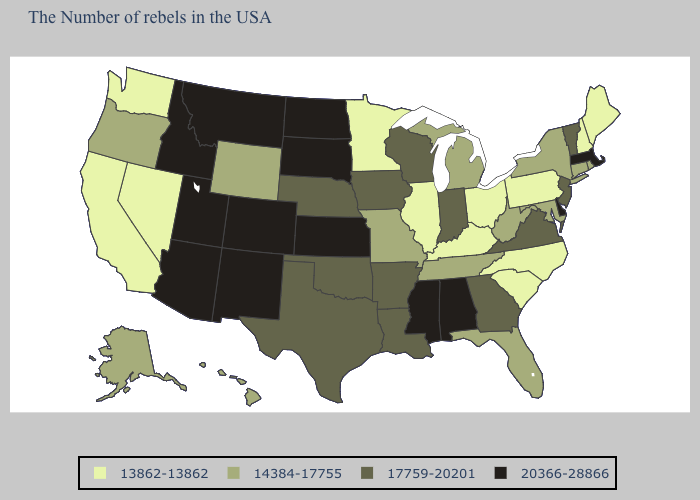Does Wyoming have a higher value than Illinois?
Keep it brief. Yes. Among the states that border Utah , does Nevada have the lowest value?
Keep it brief. Yes. Which states hav the highest value in the West?
Keep it brief. Colorado, New Mexico, Utah, Montana, Arizona, Idaho. Name the states that have a value in the range 13862-13862?
Be succinct. Maine, New Hampshire, Pennsylvania, North Carolina, South Carolina, Ohio, Kentucky, Illinois, Minnesota, Nevada, California, Washington. What is the value of Nevada?
Be succinct. 13862-13862. What is the value of Georgia?
Give a very brief answer. 17759-20201. What is the highest value in the South ?
Short answer required. 20366-28866. Name the states that have a value in the range 17759-20201?
Concise answer only. Vermont, New Jersey, Virginia, Georgia, Indiana, Wisconsin, Louisiana, Arkansas, Iowa, Nebraska, Oklahoma, Texas. Name the states that have a value in the range 13862-13862?
Concise answer only. Maine, New Hampshire, Pennsylvania, North Carolina, South Carolina, Ohio, Kentucky, Illinois, Minnesota, Nevada, California, Washington. What is the value of Virginia?
Quick response, please. 17759-20201. What is the value of South Dakota?
Be succinct. 20366-28866. Name the states that have a value in the range 14384-17755?
Answer briefly. Rhode Island, Connecticut, New York, Maryland, West Virginia, Florida, Michigan, Tennessee, Missouri, Wyoming, Oregon, Alaska, Hawaii. Name the states that have a value in the range 14384-17755?
Write a very short answer. Rhode Island, Connecticut, New York, Maryland, West Virginia, Florida, Michigan, Tennessee, Missouri, Wyoming, Oregon, Alaska, Hawaii. What is the value of Texas?
Concise answer only. 17759-20201. Does Utah have the highest value in the USA?
Answer briefly. Yes. 